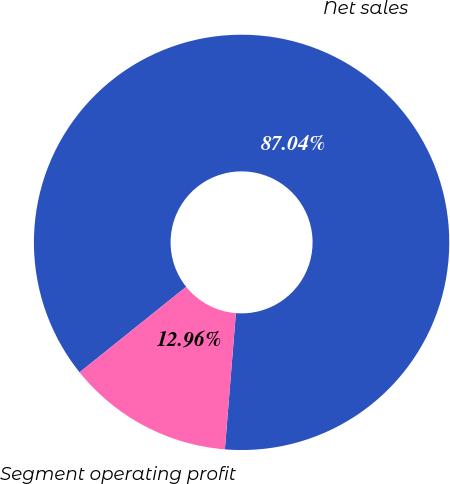<chart> <loc_0><loc_0><loc_500><loc_500><pie_chart><fcel>Net sales<fcel>Segment operating profit<nl><fcel>87.04%<fcel>12.96%<nl></chart> 